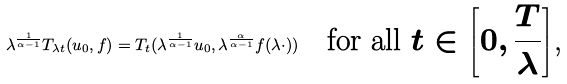<formula> <loc_0><loc_0><loc_500><loc_500>\lambda ^ { \frac { 1 } { \alpha - 1 } } T _ { \lambda t } ( u _ { 0 } , f ) = T _ { t } ( \lambda ^ { \frac { 1 } { \alpha - 1 } } u _ { 0 } , \lambda ^ { \frac { \alpha } { \alpha - 1 } } f ( \lambda \cdot ) ) \quad \text {for all $t\in \left[0,\frac{T}{\lambda}\right]$,}</formula> 